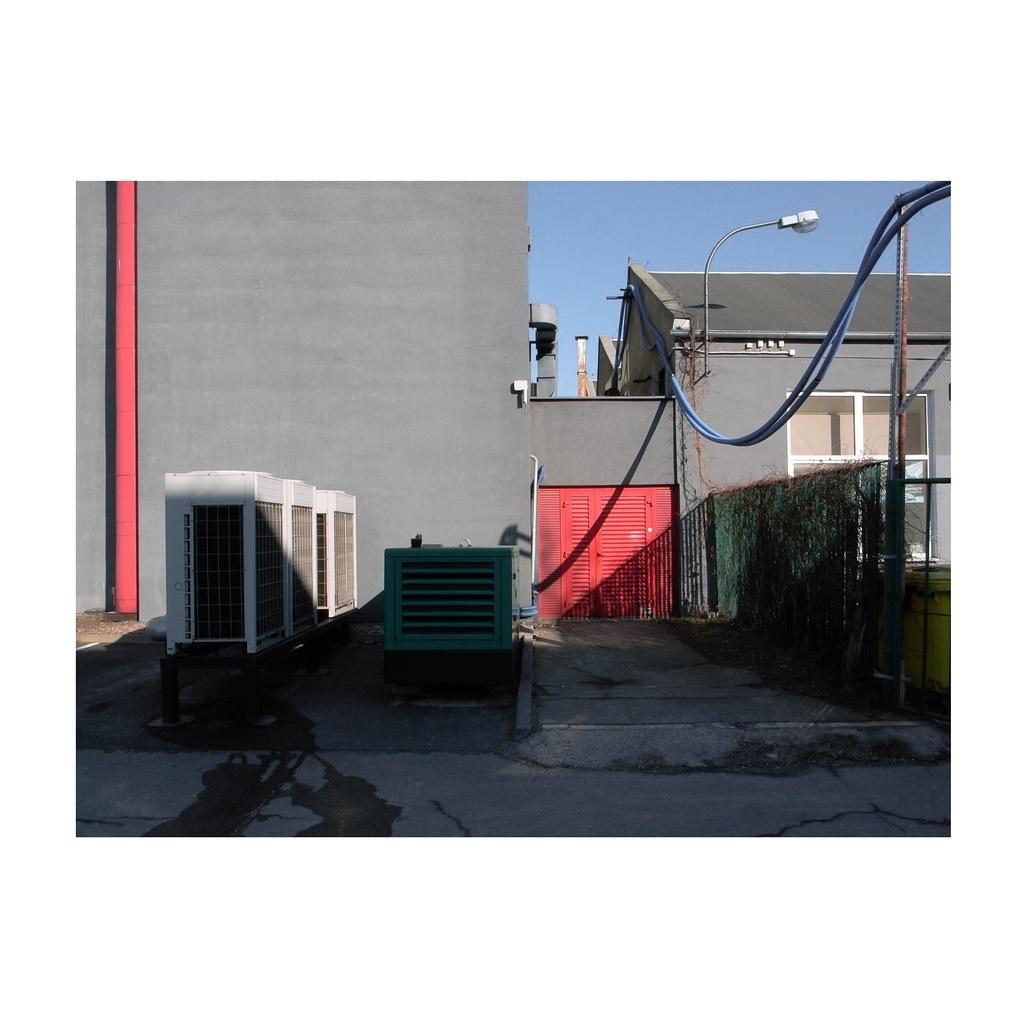What type of pathway is present in the image? There is a road in the image. What structure can be seen near the road? There is a wall in the image. What is the purpose of the tall structure near the wall? There is a light pole in the image, which is used for illumination. What type of building is visible in the image? There is a house in the image. What type of barrier is present in the image? There is a fence in the image. What device can be seen near the fence? There is a generator in the image. What other objects can be seen in the image? There are some objects in the image, but their specific details are not mentioned. What can be seen in the background of the image? The sky is visible in the background of the image. What type of silverware is being used by the business in the image? There is no mention of silverware or a business in the image. How does the motion of the objects in the image contribute to the story being told? There is no mention of motion or a story being told in the image. 